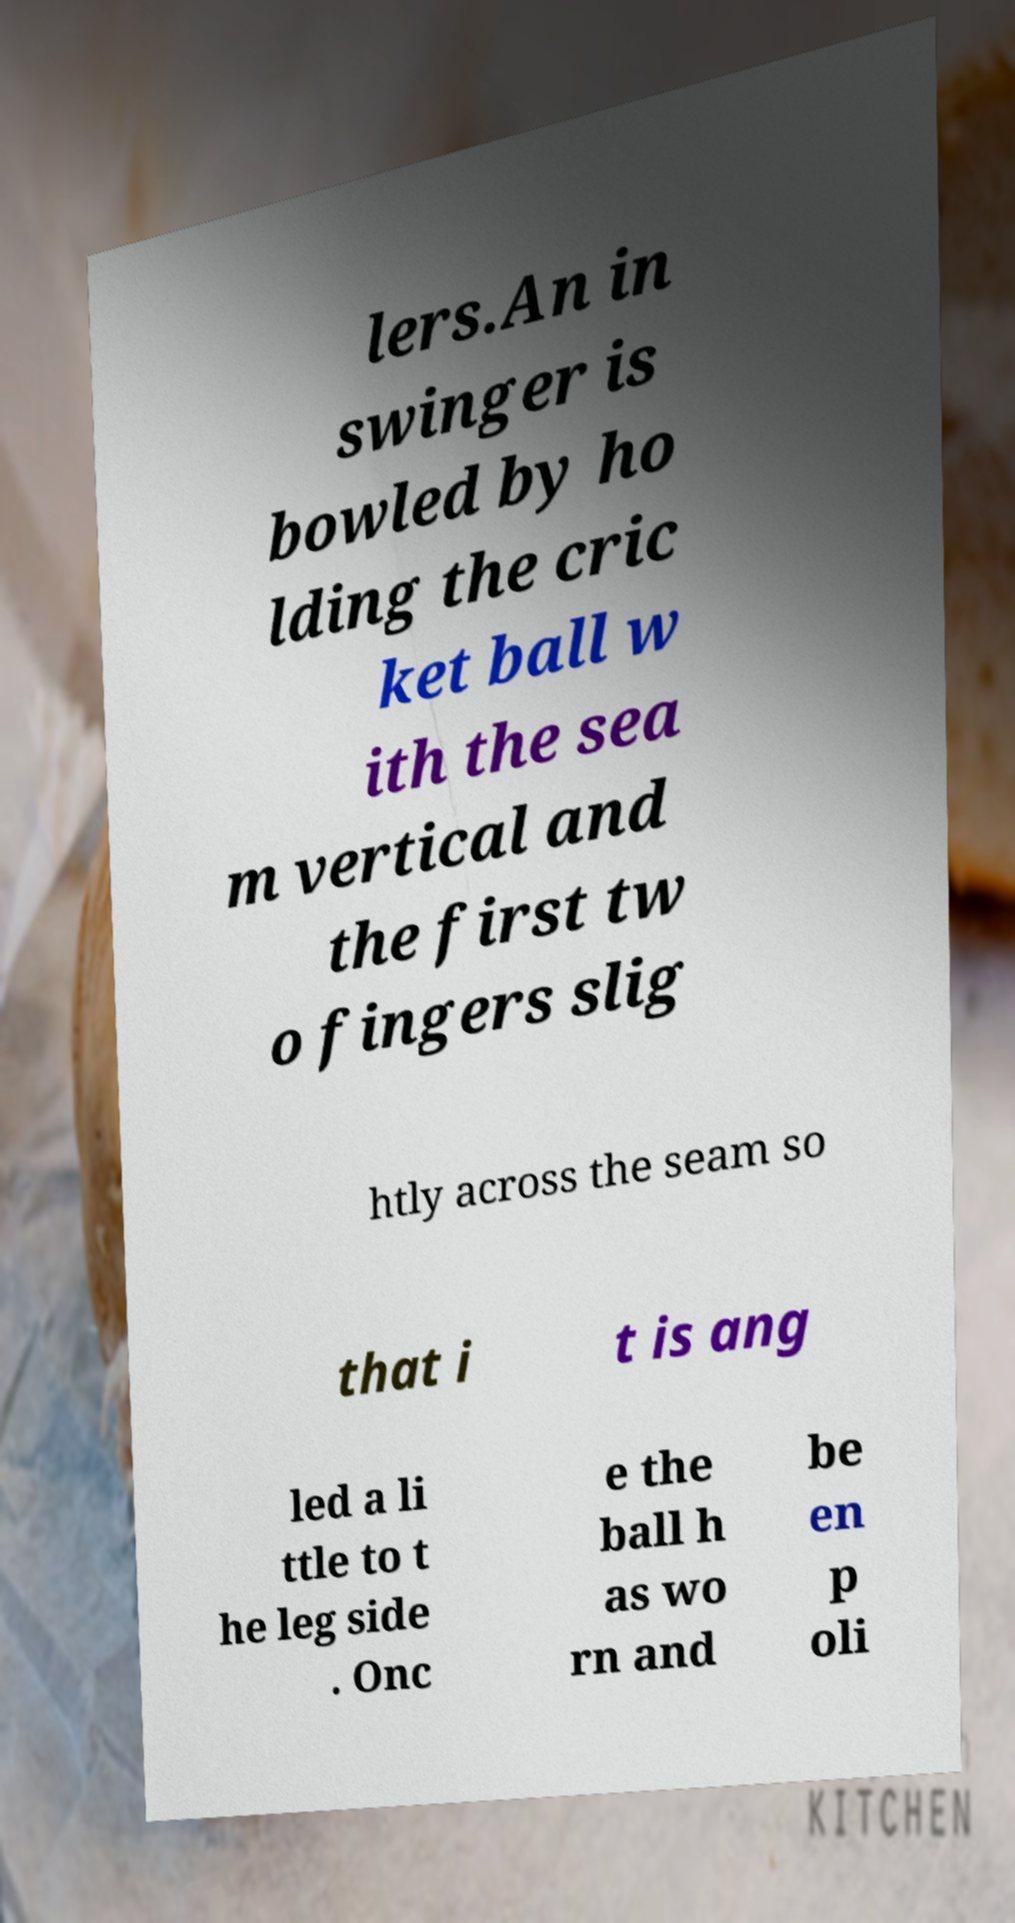Can you read and provide the text displayed in the image?This photo seems to have some interesting text. Can you extract and type it out for me? lers.An in swinger is bowled by ho lding the cric ket ball w ith the sea m vertical and the first tw o fingers slig htly across the seam so that i t is ang led a li ttle to t he leg side . Onc e the ball h as wo rn and be en p oli 